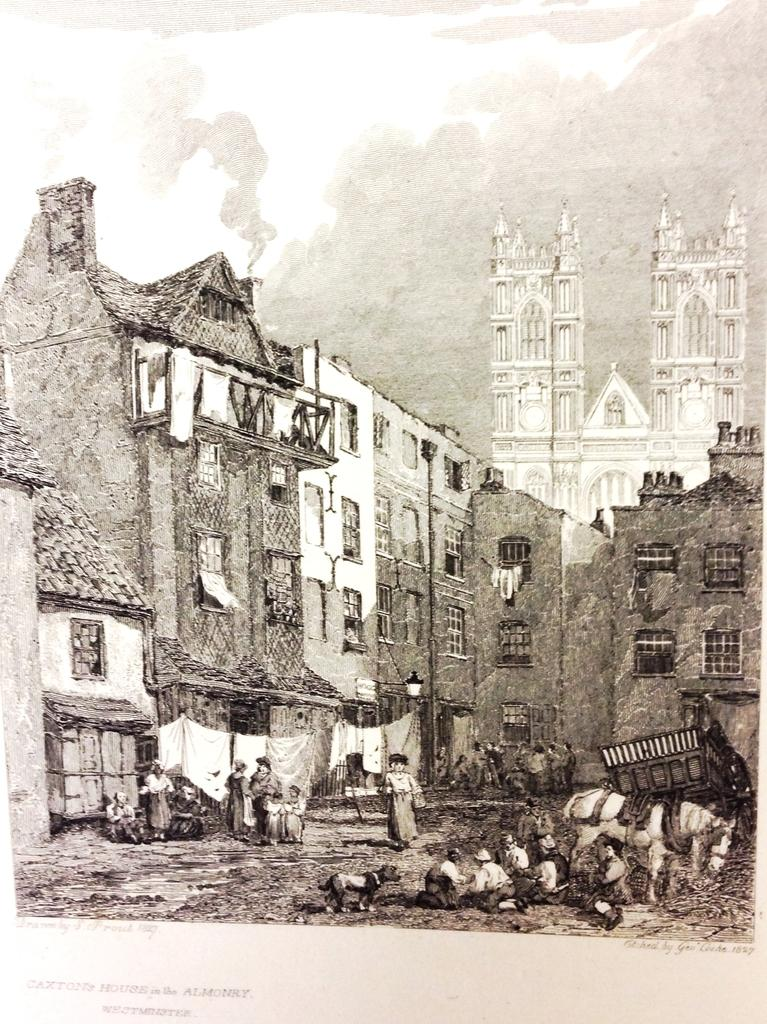What is the color scheme of the image? The image is black and white. Who or what can be seen in the image? There are people and a horse in the image. What type of material is visible in the image? There is cloth visible in the image. What type of structures are present in the image? There are buildings in the image. What part of the natural environment is visible in the image? The sky is visible in the image. What type of hammer is being used by the horse in the image? There is no hammer present in the image, and the horse is not using any tool. What are the hobbies of the people in the image? The image does not provide information about the hobbies of the people in the image. 